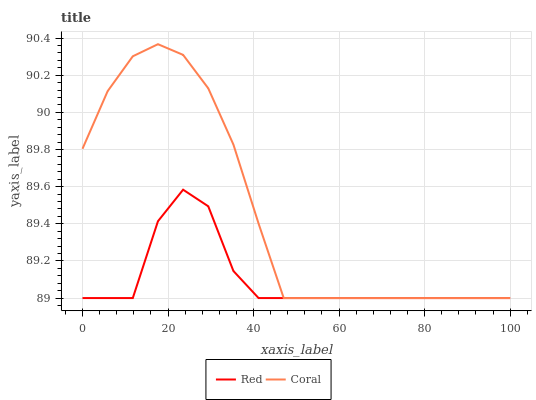Does Red have the minimum area under the curve?
Answer yes or no. Yes. Does Coral have the maximum area under the curve?
Answer yes or no. Yes. Does Red have the maximum area under the curve?
Answer yes or no. No. Is Coral the smoothest?
Answer yes or no. Yes. Is Red the roughest?
Answer yes or no. Yes. Is Red the smoothest?
Answer yes or no. No. Does Coral have the lowest value?
Answer yes or no. Yes. Does Coral have the highest value?
Answer yes or no. Yes. Does Red have the highest value?
Answer yes or no. No. Does Red intersect Coral?
Answer yes or no. Yes. Is Red less than Coral?
Answer yes or no. No. Is Red greater than Coral?
Answer yes or no. No. 